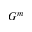<formula> <loc_0><loc_0><loc_500><loc_500>G ^ { m }</formula> 